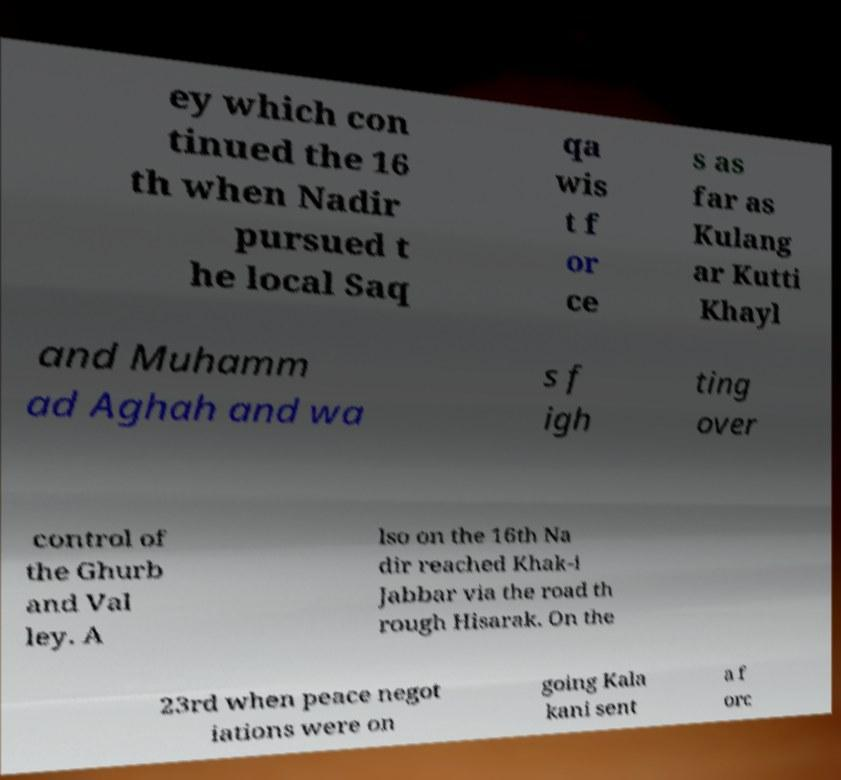Can you accurately transcribe the text from the provided image for me? ey which con tinued the 16 th when Nadir pursued t he local Saq qa wis t f or ce s as far as Kulang ar Kutti Khayl and Muhamm ad Aghah and wa s f igh ting over control of the Ghurb and Val ley. A lso on the 16th Na dir reached Khak-i Jabbar via the road th rough Hisarak. On the 23rd when peace negot iations were on going Kala kani sent a f orc 